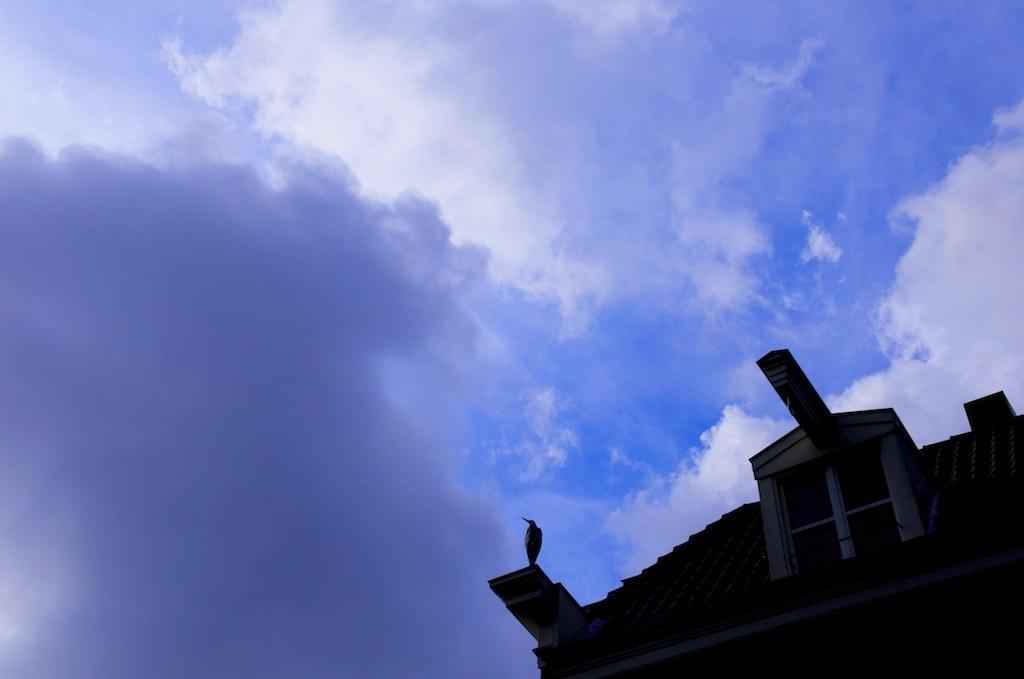Please provide a concise description of this image. In this image there is a bird standing on the building , and at the background there is sky. 